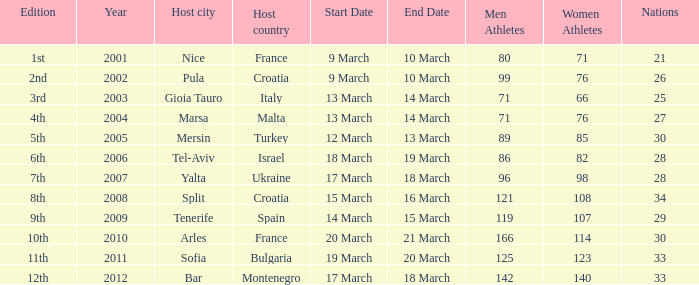Who was the host country when Bar was the host city? Montenegro. 